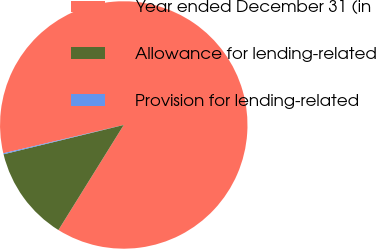Convert chart to OTSL. <chart><loc_0><loc_0><loc_500><loc_500><pie_chart><fcel>Year ended December 31 (in<fcel>Allowance for lending-related<fcel>Provision for lending-related<nl><fcel>87.53%<fcel>12.34%<fcel>0.13%<nl></chart> 